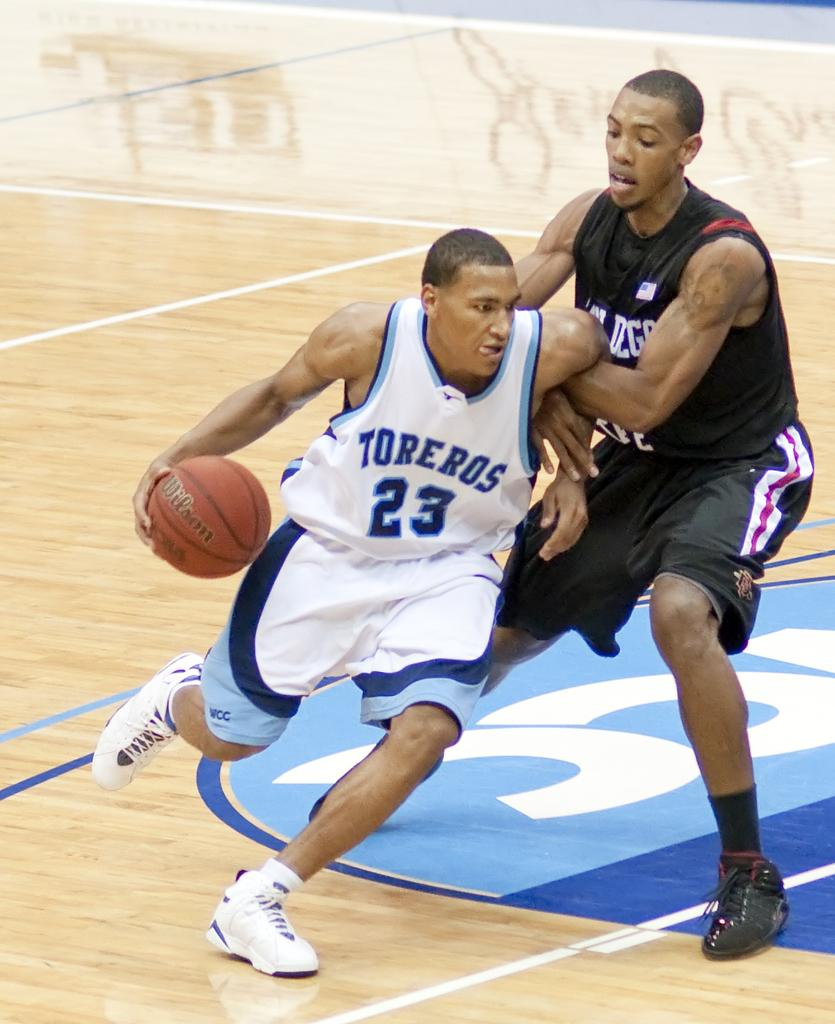How many people are in the image? There are two persons in the image. What are the two persons doing in the image? The two persons are playing basketball. Can you describe the action of one of the persons? One of the persons is holding a basketball. What type of reaction can be seen from the dog in the image? There is no dog present in the image, so it is not possible to determine any reactions from a dog. 